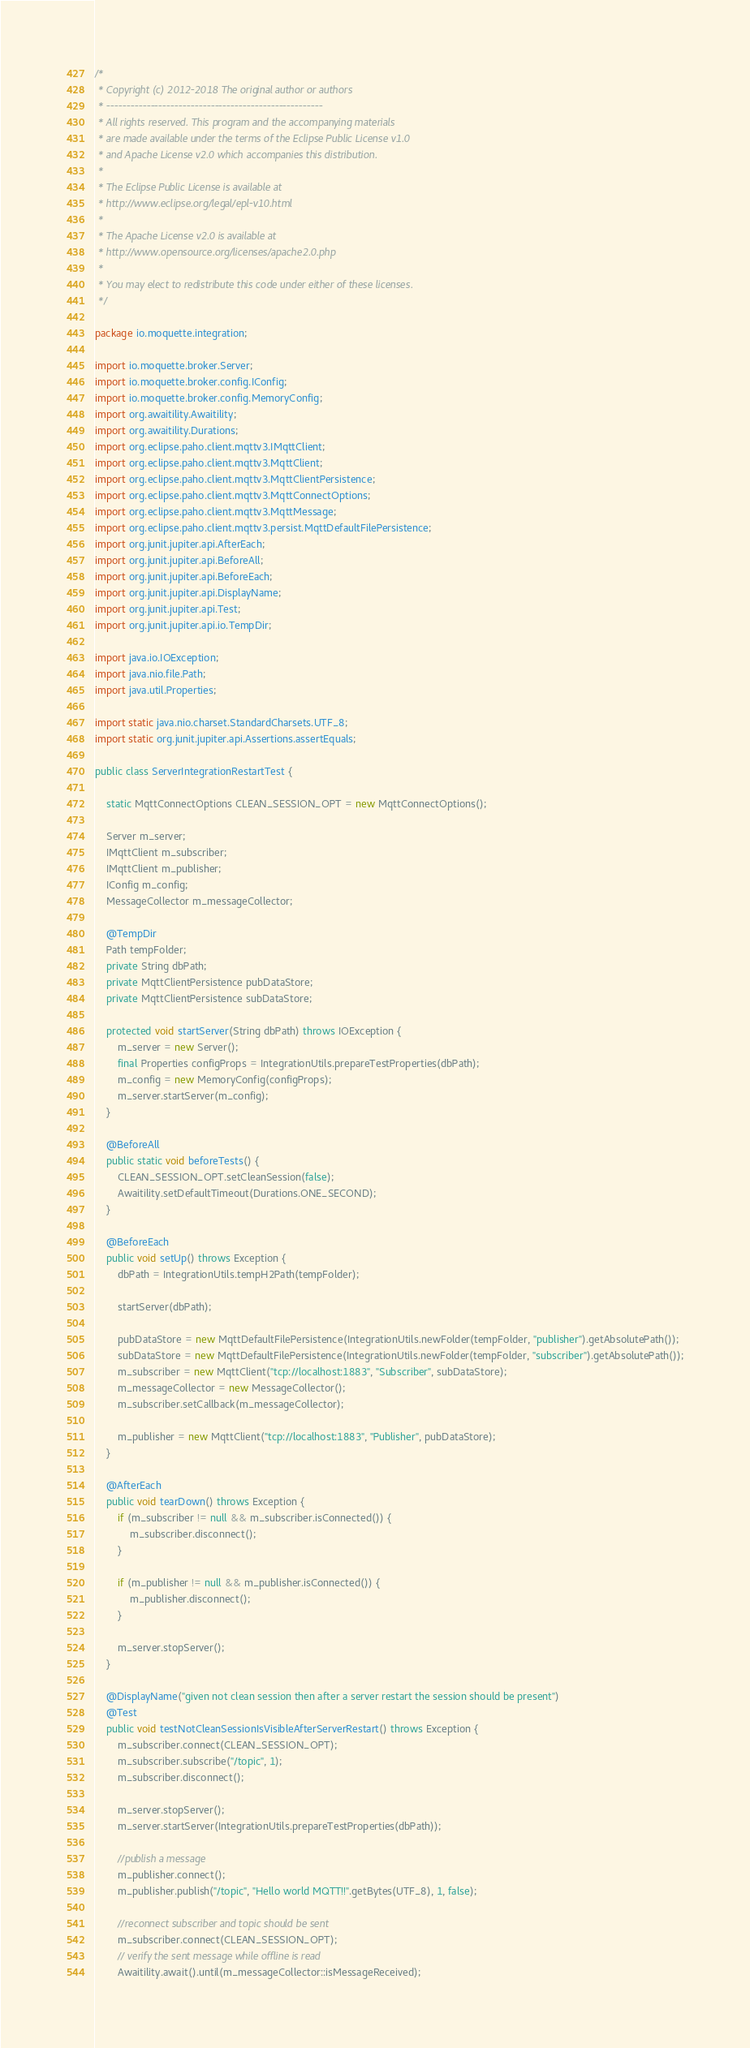<code> <loc_0><loc_0><loc_500><loc_500><_Java_>/*
 * Copyright (c) 2012-2018 The original author or authors
 * ------------------------------------------------------
 * All rights reserved. This program and the accompanying materials
 * are made available under the terms of the Eclipse Public License v1.0
 * and Apache License v2.0 which accompanies this distribution.
 *
 * The Eclipse Public License is available at
 * http://www.eclipse.org/legal/epl-v10.html
 *
 * The Apache License v2.0 is available at
 * http://www.opensource.org/licenses/apache2.0.php
 *
 * You may elect to redistribute this code under either of these licenses.
 */

package io.moquette.integration;

import io.moquette.broker.Server;
import io.moquette.broker.config.IConfig;
import io.moquette.broker.config.MemoryConfig;
import org.awaitility.Awaitility;
import org.awaitility.Durations;
import org.eclipse.paho.client.mqttv3.IMqttClient;
import org.eclipse.paho.client.mqttv3.MqttClient;
import org.eclipse.paho.client.mqttv3.MqttClientPersistence;
import org.eclipse.paho.client.mqttv3.MqttConnectOptions;
import org.eclipse.paho.client.mqttv3.MqttMessage;
import org.eclipse.paho.client.mqttv3.persist.MqttDefaultFilePersistence;
import org.junit.jupiter.api.AfterEach;
import org.junit.jupiter.api.BeforeAll;
import org.junit.jupiter.api.BeforeEach;
import org.junit.jupiter.api.DisplayName;
import org.junit.jupiter.api.Test;
import org.junit.jupiter.api.io.TempDir;

import java.io.IOException;
import java.nio.file.Path;
import java.util.Properties;

import static java.nio.charset.StandardCharsets.UTF_8;
import static org.junit.jupiter.api.Assertions.assertEquals;

public class ServerIntegrationRestartTest {

    static MqttConnectOptions CLEAN_SESSION_OPT = new MqttConnectOptions();

    Server m_server;
    IMqttClient m_subscriber;
    IMqttClient m_publisher;
    IConfig m_config;
    MessageCollector m_messageCollector;

    @TempDir
    Path tempFolder;
    private String dbPath;
    private MqttClientPersistence pubDataStore;
    private MqttClientPersistence subDataStore;

    protected void startServer(String dbPath) throws IOException {
        m_server = new Server();
        final Properties configProps = IntegrationUtils.prepareTestProperties(dbPath);
        m_config = new MemoryConfig(configProps);
        m_server.startServer(m_config);
    }

    @BeforeAll
    public static void beforeTests() {
        CLEAN_SESSION_OPT.setCleanSession(false);
        Awaitility.setDefaultTimeout(Durations.ONE_SECOND);
    }

    @BeforeEach
    public void setUp() throws Exception {
        dbPath = IntegrationUtils.tempH2Path(tempFolder);

        startServer(dbPath);

        pubDataStore = new MqttDefaultFilePersistence(IntegrationUtils.newFolder(tempFolder, "publisher").getAbsolutePath());
        subDataStore = new MqttDefaultFilePersistence(IntegrationUtils.newFolder(tempFolder, "subscriber").getAbsolutePath());
        m_subscriber = new MqttClient("tcp://localhost:1883", "Subscriber", subDataStore);
        m_messageCollector = new MessageCollector();
        m_subscriber.setCallback(m_messageCollector);

        m_publisher = new MqttClient("tcp://localhost:1883", "Publisher", pubDataStore);
    }

    @AfterEach
    public void tearDown() throws Exception {
        if (m_subscriber != null && m_subscriber.isConnected()) {
            m_subscriber.disconnect();
        }

        if (m_publisher != null && m_publisher.isConnected()) {
            m_publisher.disconnect();
        }

        m_server.stopServer();
    }

    @DisplayName("given not clean session then after a server restart the session should be present")
    @Test
    public void testNotCleanSessionIsVisibleAfterServerRestart() throws Exception {
        m_subscriber.connect(CLEAN_SESSION_OPT);
        m_subscriber.subscribe("/topic", 1);
        m_subscriber.disconnect();

        m_server.stopServer();
        m_server.startServer(IntegrationUtils.prepareTestProperties(dbPath));

        //publish a message
        m_publisher.connect();
        m_publisher.publish("/topic", "Hello world MQTT!!".getBytes(UTF_8), 1, false);

        //reconnect subscriber and topic should be sent
        m_subscriber.connect(CLEAN_SESSION_OPT);
        // verify the sent message while offline is read
        Awaitility.await().until(m_messageCollector::isMessageReceived);</code> 